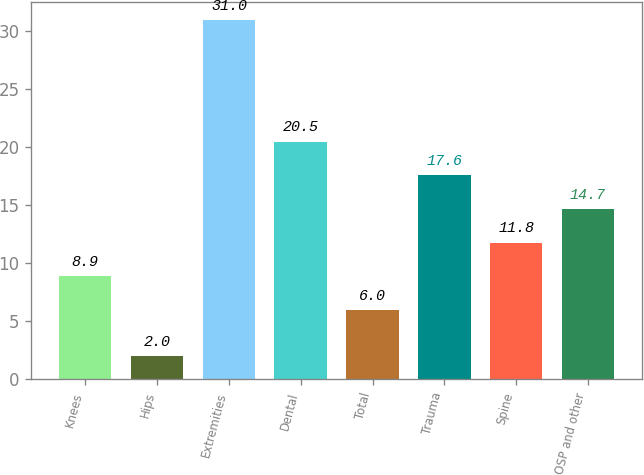Convert chart to OTSL. <chart><loc_0><loc_0><loc_500><loc_500><bar_chart><fcel>Knees<fcel>Hips<fcel>Extremities<fcel>Dental<fcel>Total<fcel>Trauma<fcel>Spine<fcel>OSP and other<nl><fcel>8.9<fcel>2<fcel>31<fcel>20.5<fcel>6<fcel>17.6<fcel>11.8<fcel>14.7<nl></chart> 